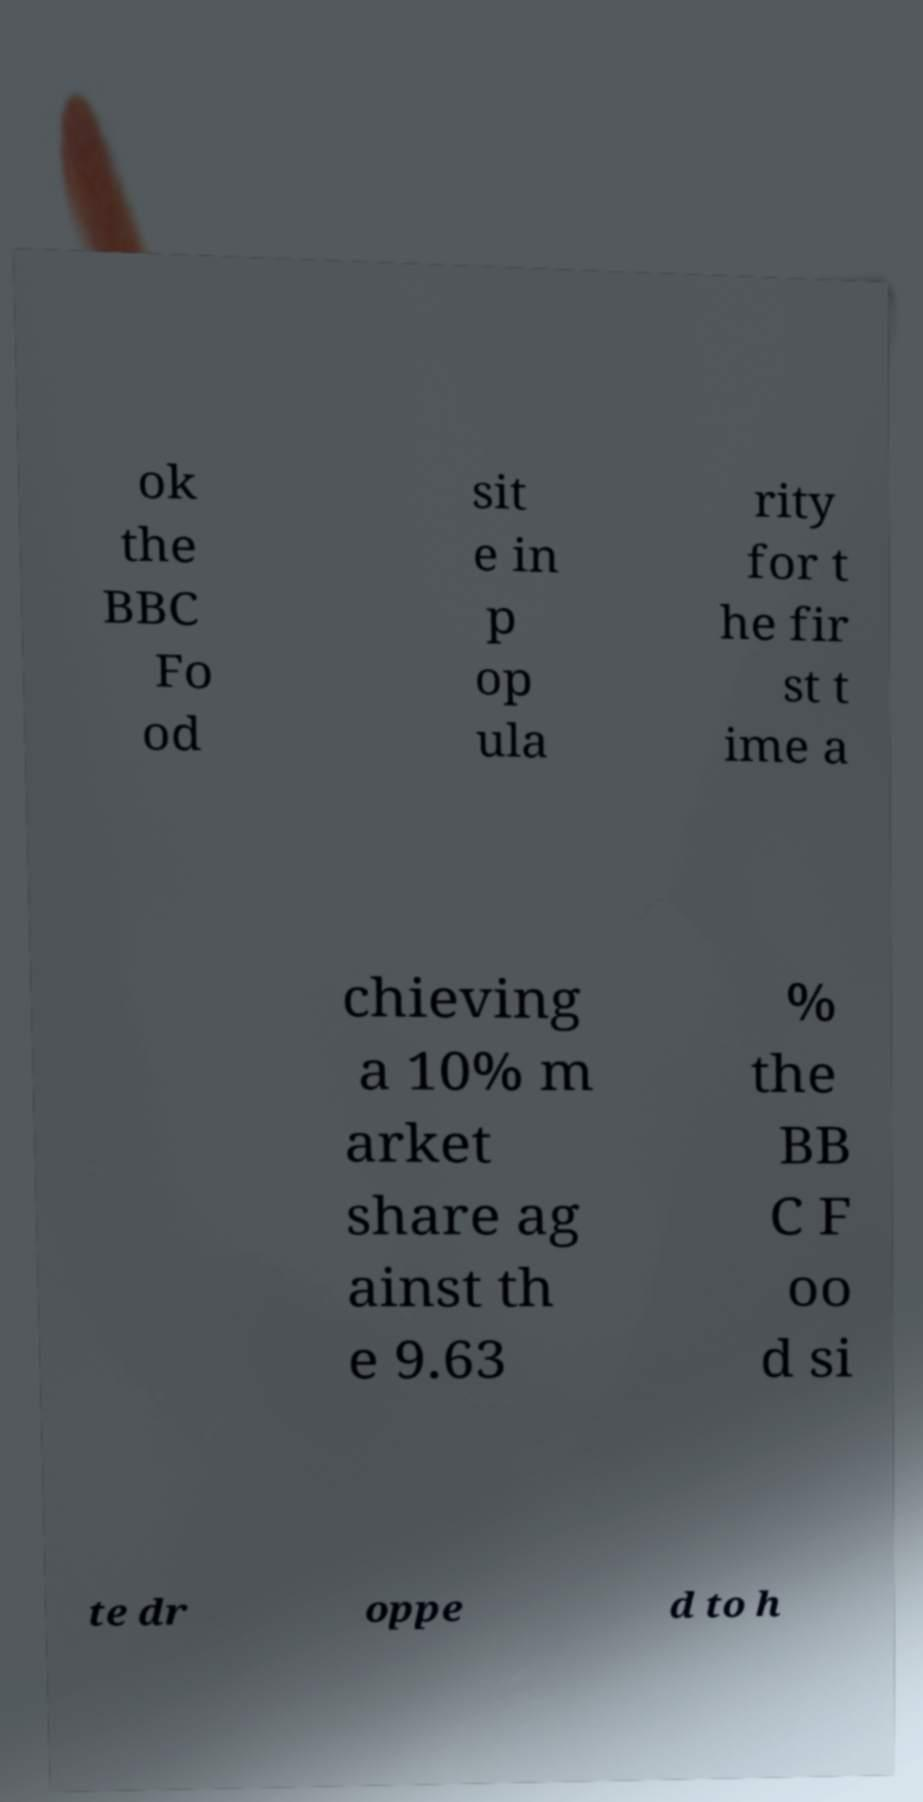Can you read and provide the text displayed in the image?This photo seems to have some interesting text. Can you extract and type it out for me? ok the BBC Fo od sit e in p op ula rity for t he fir st t ime a chieving a 10% m arket share ag ainst th e 9.63 % the BB C F oo d si te dr oppe d to h 